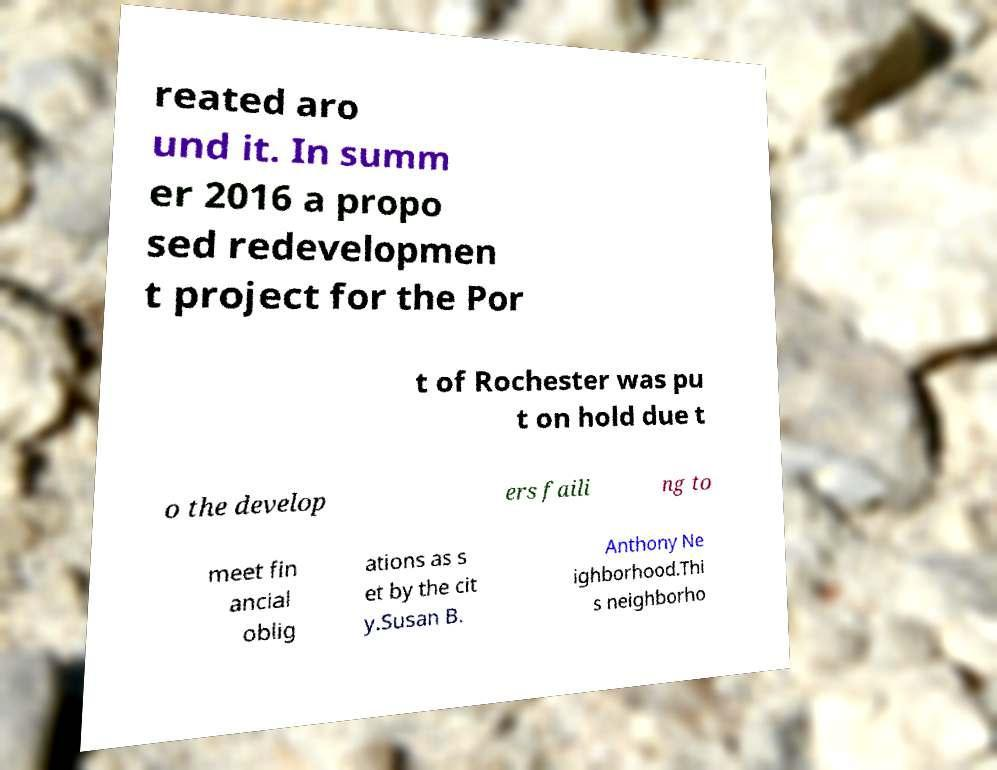Can you read and provide the text displayed in the image?This photo seems to have some interesting text. Can you extract and type it out for me? reated aro und it. In summ er 2016 a propo sed redevelopmen t project for the Por t of Rochester was pu t on hold due t o the develop ers faili ng to meet fin ancial oblig ations as s et by the cit y.Susan B. Anthony Ne ighborhood.Thi s neighborho 